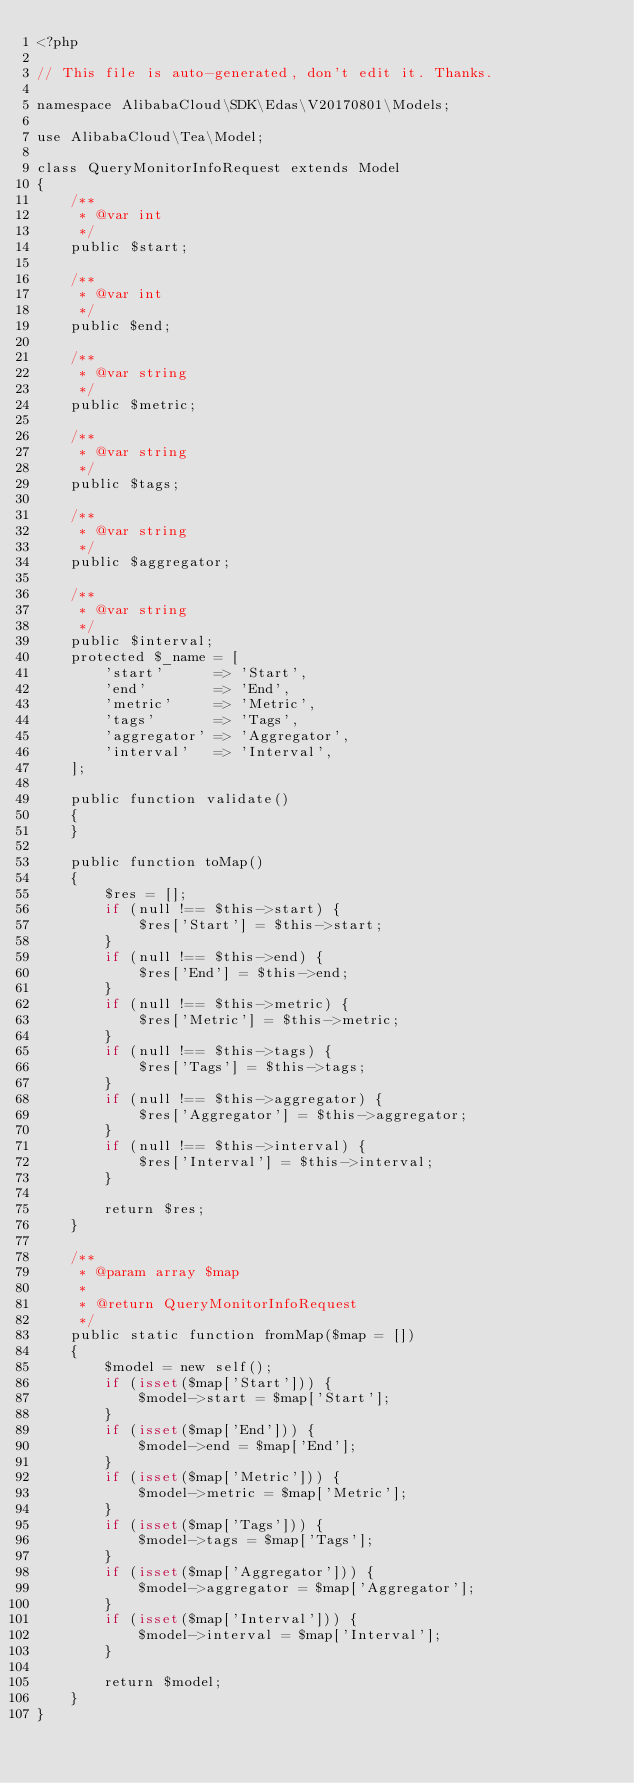<code> <loc_0><loc_0><loc_500><loc_500><_PHP_><?php

// This file is auto-generated, don't edit it. Thanks.

namespace AlibabaCloud\SDK\Edas\V20170801\Models;

use AlibabaCloud\Tea\Model;

class QueryMonitorInfoRequest extends Model
{
    /**
     * @var int
     */
    public $start;

    /**
     * @var int
     */
    public $end;

    /**
     * @var string
     */
    public $metric;

    /**
     * @var string
     */
    public $tags;

    /**
     * @var string
     */
    public $aggregator;

    /**
     * @var string
     */
    public $interval;
    protected $_name = [
        'start'      => 'Start',
        'end'        => 'End',
        'metric'     => 'Metric',
        'tags'       => 'Tags',
        'aggregator' => 'Aggregator',
        'interval'   => 'Interval',
    ];

    public function validate()
    {
    }

    public function toMap()
    {
        $res = [];
        if (null !== $this->start) {
            $res['Start'] = $this->start;
        }
        if (null !== $this->end) {
            $res['End'] = $this->end;
        }
        if (null !== $this->metric) {
            $res['Metric'] = $this->metric;
        }
        if (null !== $this->tags) {
            $res['Tags'] = $this->tags;
        }
        if (null !== $this->aggregator) {
            $res['Aggregator'] = $this->aggregator;
        }
        if (null !== $this->interval) {
            $res['Interval'] = $this->interval;
        }

        return $res;
    }

    /**
     * @param array $map
     *
     * @return QueryMonitorInfoRequest
     */
    public static function fromMap($map = [])
    {
        $model = new self();
        if (isset($map['Start'])) {
            $model->start = $map['Start'];
        }
        if (isset($map['End'])) {
            $model->end = $map['End'];
        }
        if (isset($map['Metric'])) {
            $model->metric = $map['Metric'];
        }
        if (isset($map['Tags'])) {
            $model->tags = $map['Tags'];
        }
        if (isset($map['Aggregator'])) {
            $model->aggregator = $map['Aggregator'];
        }
        if (isset($map['Interval'])) {
            $model->interval = $map['Interval'];
        }

        return $model;
    }
}
</code> 